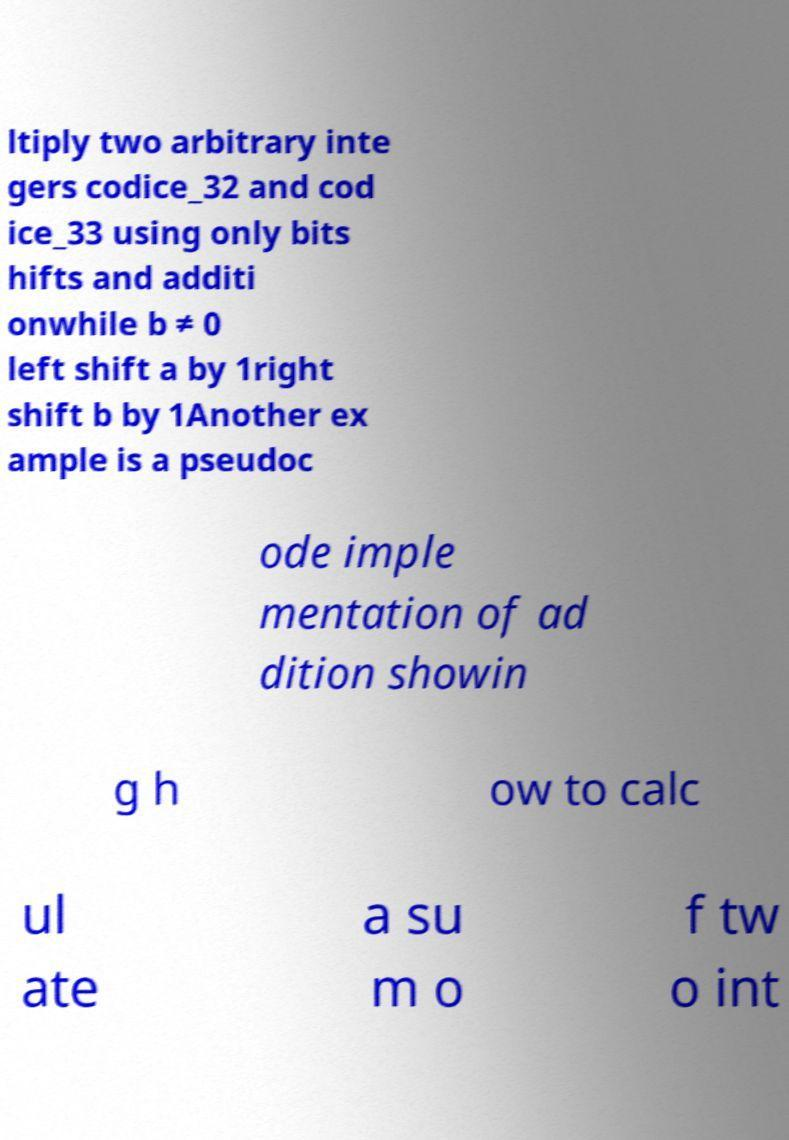There's text embedded in this image that I need extracted. Can you transcribe it verbatim? ltiply two arbitrary inte gers codice_32 and cod ice_33 using only bits hifts and additi onwhile b ≠ 0 left shift a by 1right shift b by 1Another ex ample is a pseudoc ode imple mentation of ad dition showin g h ow to calc ul ate a su m o f tw o int 